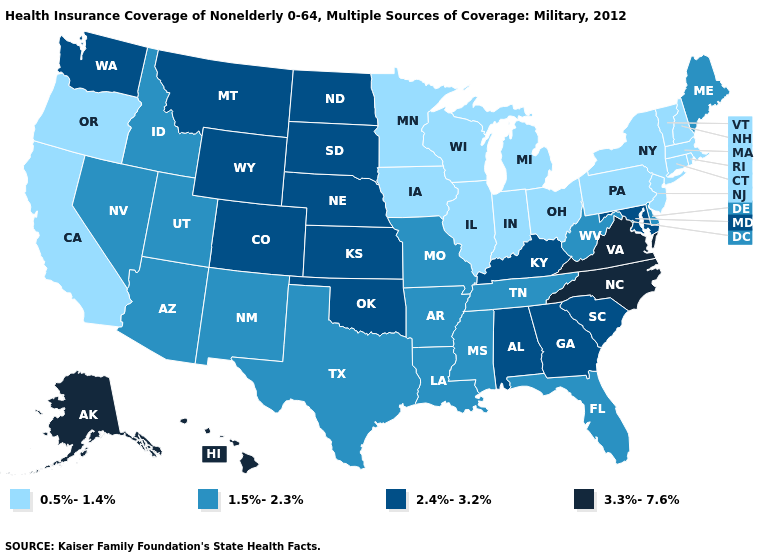What is the value of Mississippi?
Give a very brief answer. 1.5%-2.3%. Name the states that have a value in the range 1.5%-2.3%?
Be succinct. Arizona, Arkansas, Delaware, Florida, Idaho, Louisiana, Maine, Mississippi, Missouri, Nevada, New Mexico, Tennessee, Texas, Utah, West Virginia. Does California have the highest value in the West?
Short answer required. No. Does Indiana have the highest value in the USA?
Write a very short answer. No. Among the states that border Montana , which have the lowest value?
Concise answer only. Idaho. Does Kentucky have the highest value in the USA?
Answer briefly. No. Among the states that border Oklahoma , which have the highest value?
Keep it brief. Colorado, Kansas. Among the states that border Iowa , which have the lowest value?
Quick response, please. Illinois, Minnesota, Wisconsin. Name the states that have a value in the range 2.4%-3.2%?
Concise answer only. Alabama, Colorado, Georgia, Kansas, Kentucky, Maryland, Montana, Nebraska, North Dakota, Oklahoma, South Carolina, South Dakota, Washington, Wyoming. What is the value of Kansas?
Be succinct. 2.4%-3.2%. What is the value of Georgia?
Concise answer only. 2.4%-3.2%. Is the legend a continuous bar?
Short answer required. No. Among the states that border New Mexico , which have the lowest value?
Answer briefly. Arizona, Texas, Utah. What is the value of Texas?
Short answer required. 1.5%-2.3%. What is the value of Tennessee?
Give a very brief answer. 1.5%-2.3%. 